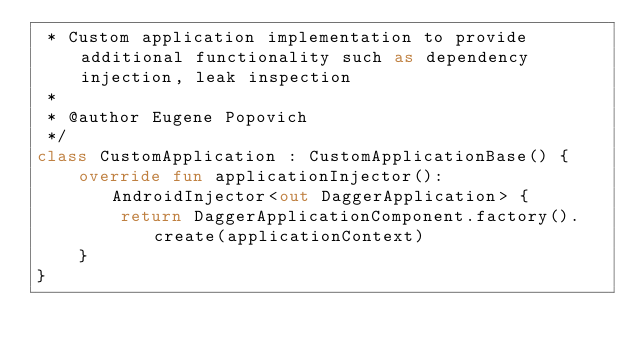Convert code to text. <code><loc_0><loc_0><loc_500><loc_500><_Kotlin_> * Custom application implementation to provide additional functionality such as dependency injection, leak inspection
 *
 * @author Eugene Popovich
 */
class CustomApplication : CustomApplicationBase() {
    override fun applicationInjector(): AndroidInjector<out DaggerApplication> {
        return DaggerApplicationComponent.factory().create(applicationContext)
    }
}</code> 